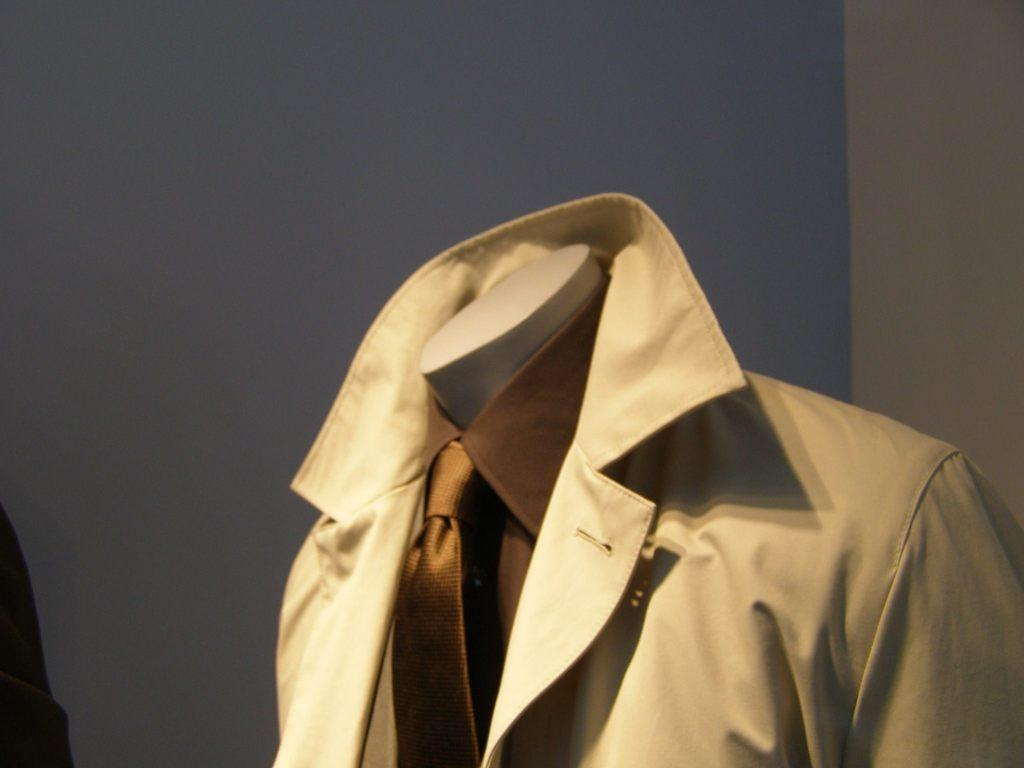What type of clothing accessory is in the image? There is a tie in the image. What type of clothing is also present in the image? There is a jacket in the image. What can be seen in the background of the image? There is a wall in the background of the image. Can you see any operations being performed on the arm in the image? There is no arm or operation present in the image; it only features a tie and a jacket. 